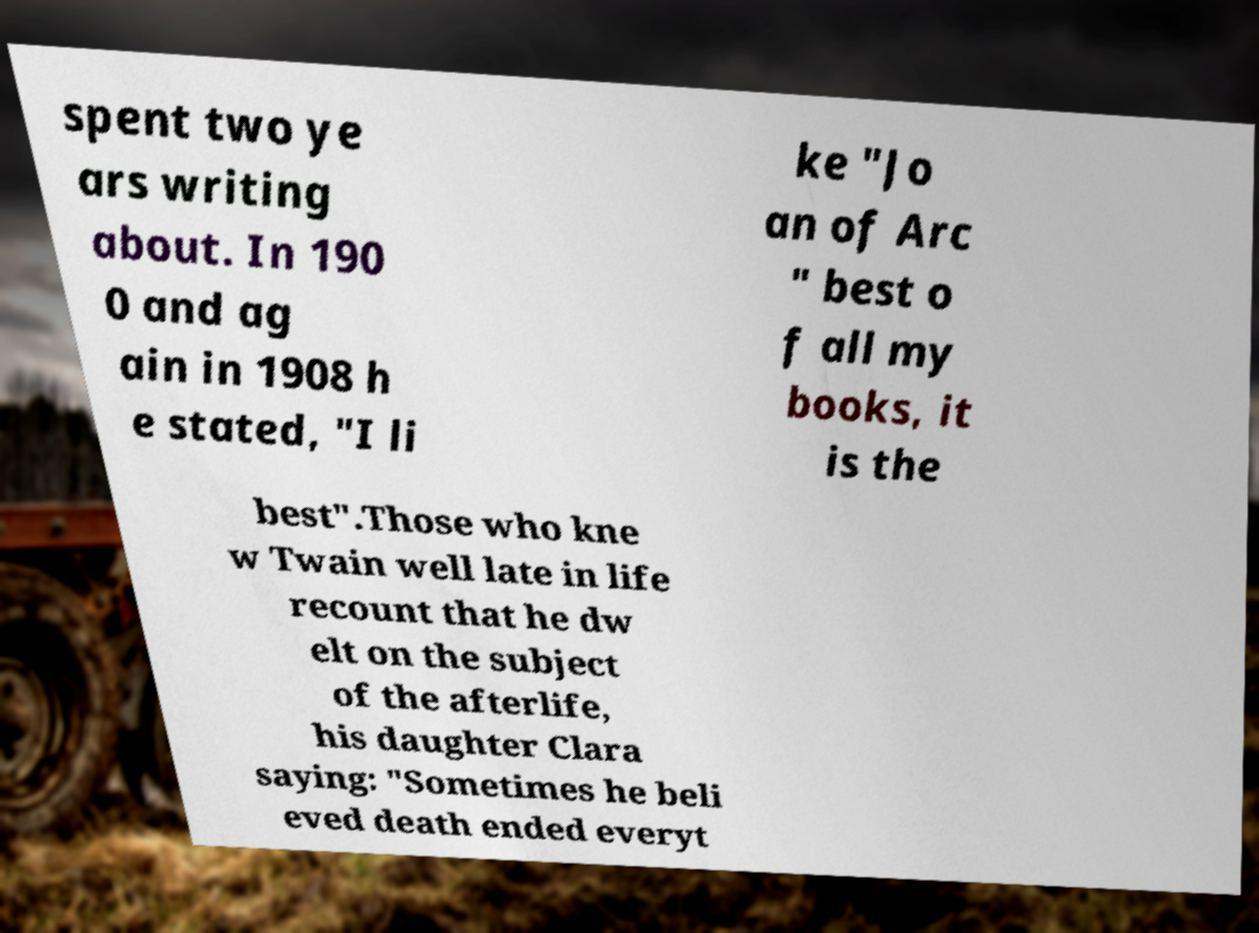There's text embedded in this image that I need extracted. Can you transcribe it verbatim? spent two ye ars writing about. In 190 0 and ag ain in 1908 h e stated, "I li ke "Jo an of Arc " best o f all my books, it is the best".Those who kne w Twain well late in life recount that he dw elt on the subject of the afterlife, his daughter Clara saying: "Sometimes he beli eved death ended everyt 